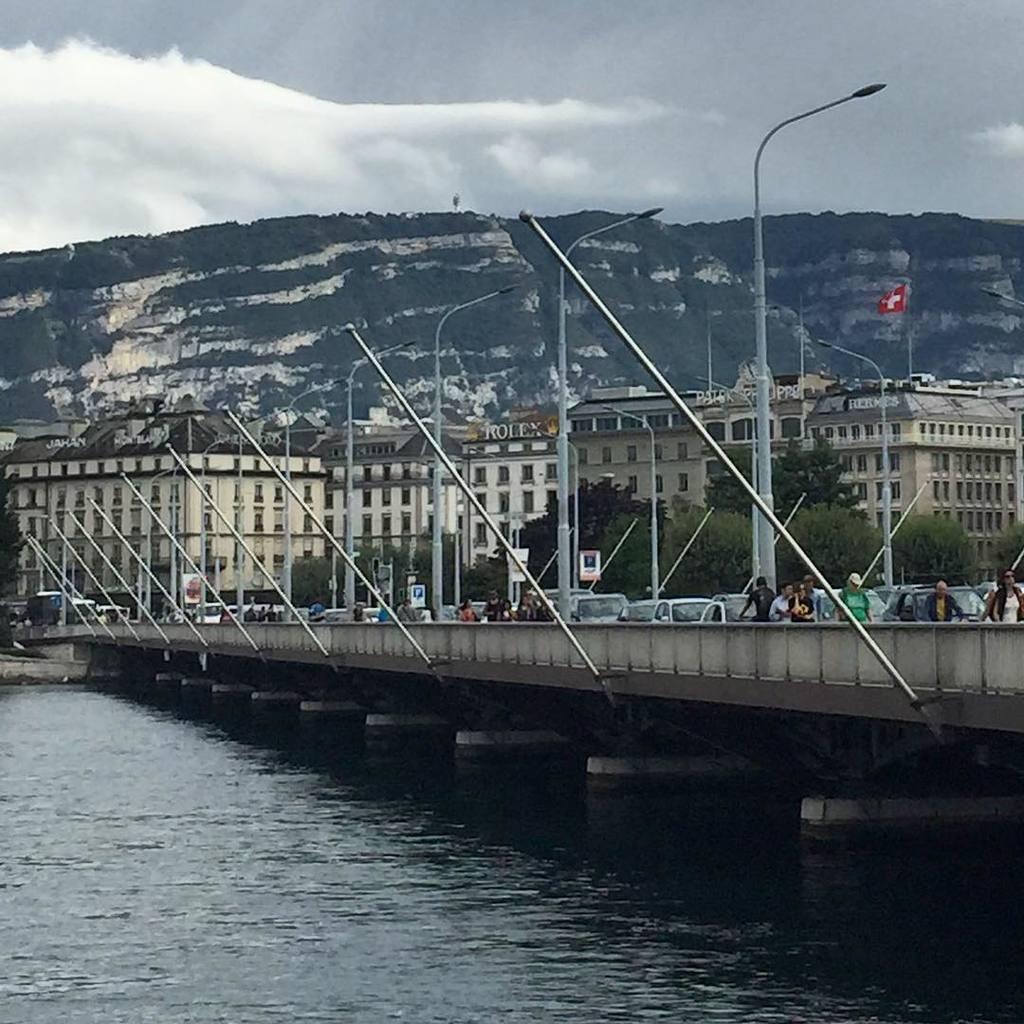How would you summarize this image in a sentence or two? In the image we can see the light poles and buildings. Here we can see the water, mountain and the cloudy sky. We can see there are even many people wearing clothes and there are even vehicles. 